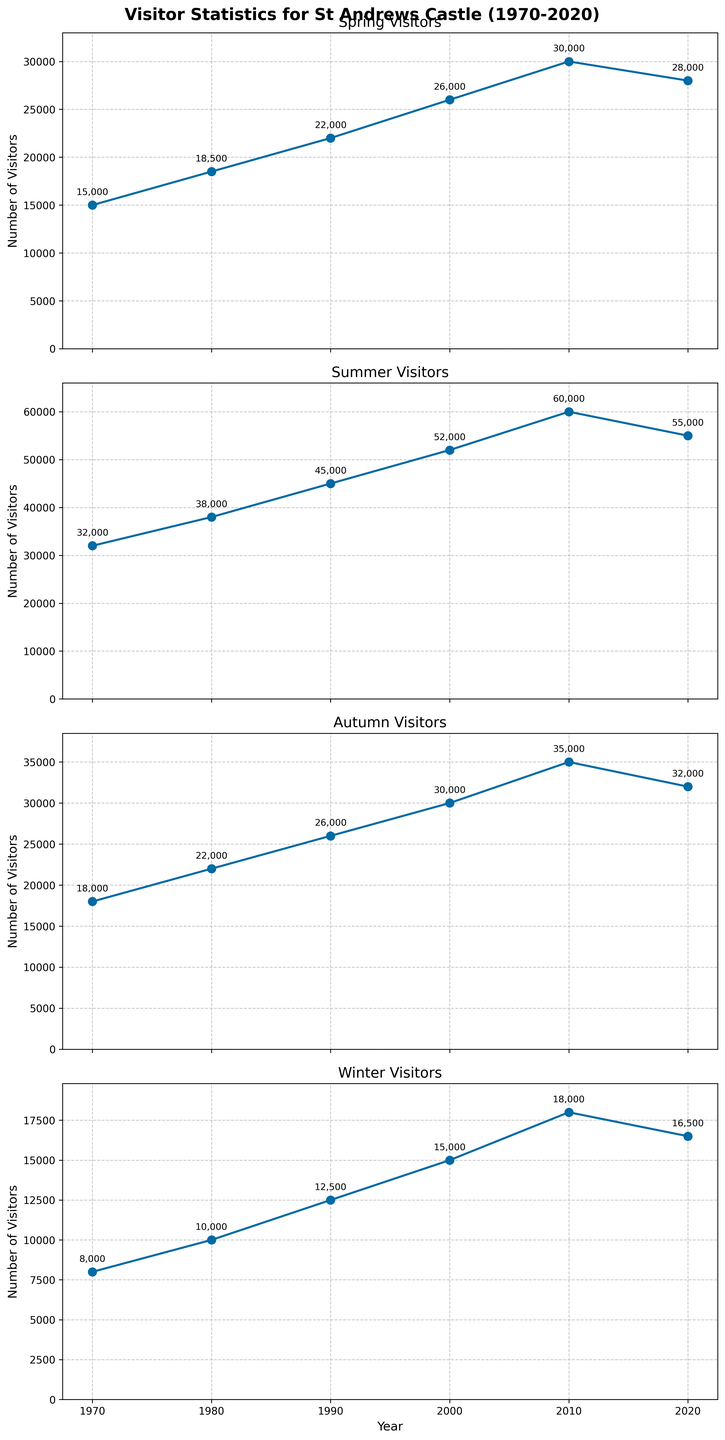Which season consistently had the highest number of visitors? Based on the plot, each season has a titled subplot showing the number of visitors over time. The Summer plot consistently shows the highest number of visitors in each year.
Answer: Summer What is the overall trend in the number of visitors for Winter from 1970 to 2020? The plot for Winter Visitors shows an increasing trend. From 1970 to 2010, the number of Winter visitors increased from 8,000 to 18,000 and slightly decreased to 16,500 in 2020.
Answer: Increasing Which year had the highest number of Autumn visitors? By checking the Autumn subplot, the highest point on the y-axis is in the year 2010, with 35,000 visitors.
Answer: 2010 How many visitors did St Andrews Castle attract in Summer in 2000 compared to 2020? From the Summer subplot, the number of visitors in 2000 is 52,000 and in 2020 is 55,000. The difference is 55,000 - 52,000 = 3,000 more visitors in 2020.
Answer: 3,000 more What is the range of visitors in Spring over the years? The range is calculated by subtracting the minimum value from the maximum value in the Spring subplot. The highest value is 30,000 in 2010 and the lowest value is 15,000 in 1970. The range is 30,000 - 15,000 = 15,000.
Answer: 15,000 Which year saw the most significant increase in Winter visitors compared to the previous year shown? Reviewing Winter subplot, the most significant increase is between 1990 and 2000, from 12,500 to 15,000, which is an increase of 2,500 visitors.
Answer: Between 1990 and 2000 How did the number of Summer visitors change between 1980 and 2010? In the Summer subplot, the number of visitors in 1980 is 38,000 and in 2010 is 60,000, showing an increase of 60,000 - 38,000 = 22,000 visitors.
Answer: Increased by 22,000 Is there any season that experienced a decline in the number of visitors from 2010 to 2020? From the subplots, Spring and Winter experienced a slight decline from 2010 to 2020, with Spring falling from 30,000 to 28,000 and Winter from 18,000 to 16,500.
Answer: Spring and Winter 